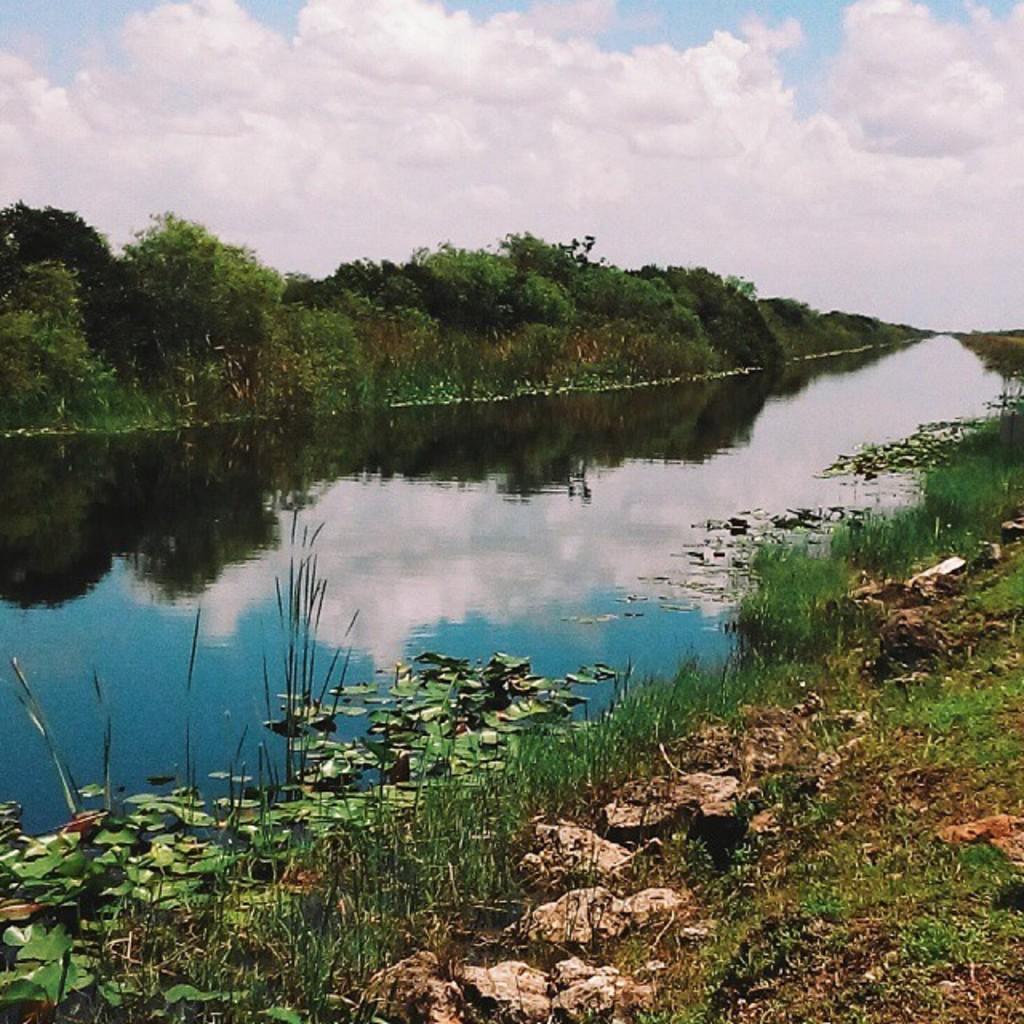How would you summarize this image in a sentence or two? As we can see in the image there is grass, water, trees, sky and clouds. 